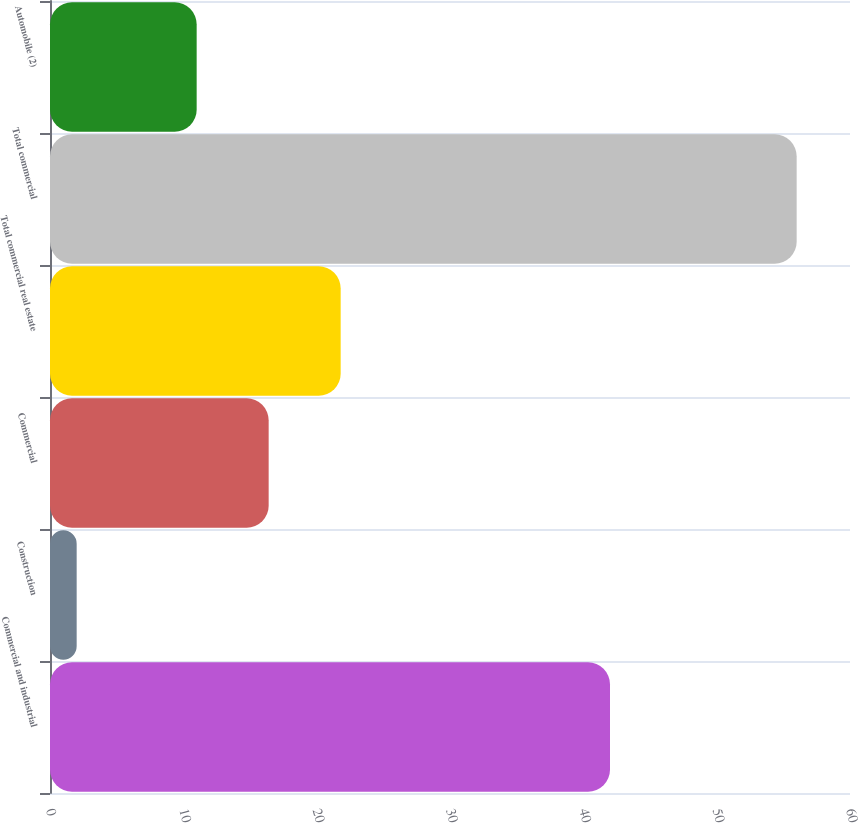Convert chart to OTSL. <chart><loc_0><loc_0><loc_500><loc_500><bar_chart><fcel>Commercial and industrial<fcel>Construction<fcel>Commercial<fcel>Total commercial real estate<fcel>Total commercial<fcel>Automobile (2)<nl><fcel>42<fcel>2<fcel>16.4<fcel>21.8<fcel>56<fcel>11<nl></chart> 